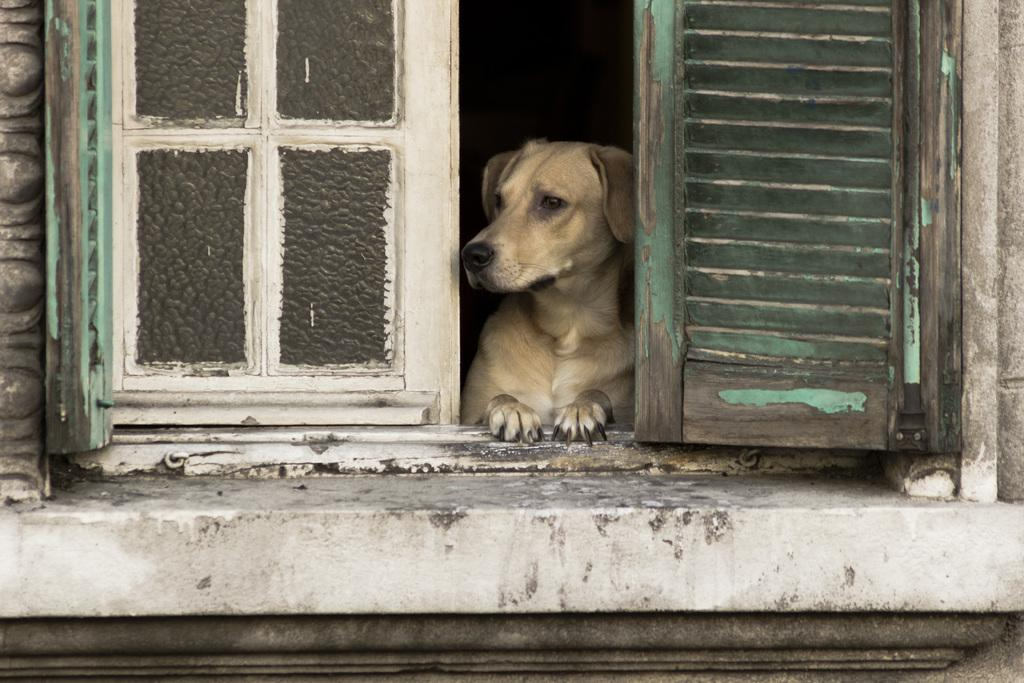What type of animal can be seen in the image? There is a dog in the image. What architectural feature is present in the image? There is a window and a wall in the image. What is the color of the background in the image? The background of the image is dark. What day of the week is depicted in the image? There is no indication of a specific day of the week in the image. What type of riddle can be solved by looking at the image? There is no riddle present in the image. 